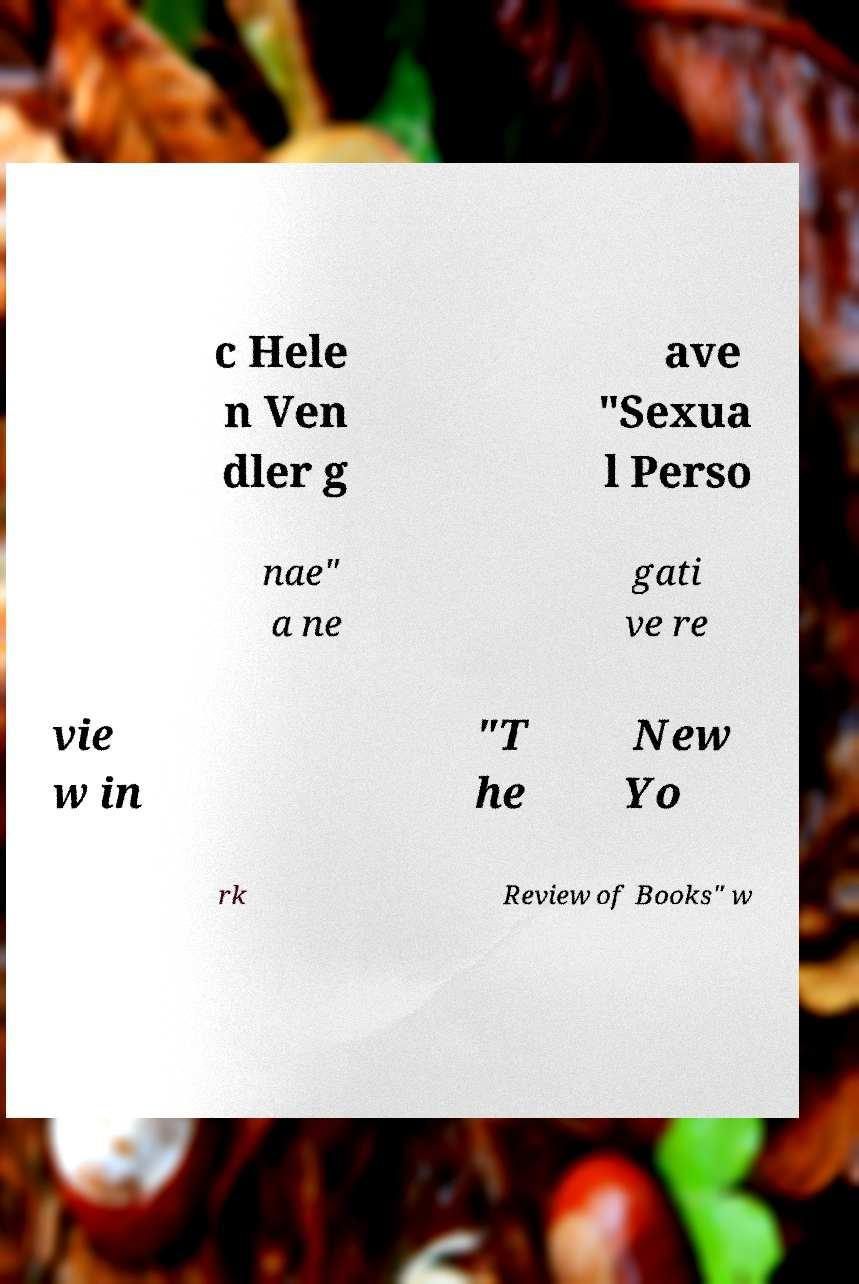Please identify and transcribe the text found in this image. c Hele n Ven dler g ave "Sexua l Perso nae" a ne gati ve re vie w in "T he New Yo rk Review of Books" w 